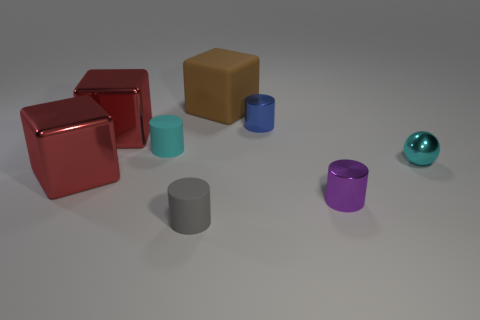What shape is the object behind the blue metallic object? cube 